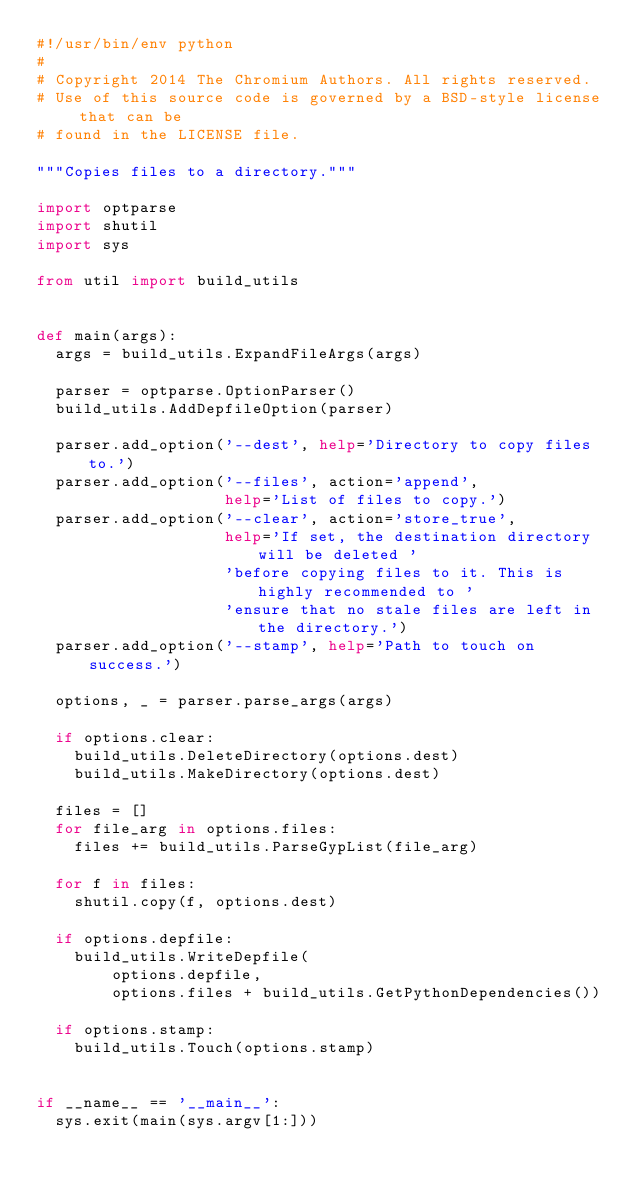Convert code to text. <code><loc_0><loc_0><loc_500><loc_500><_Python_>#!/usr/bin/env python
#
# Copyright 2014 The Chromium Authors. All rights reserved.
# Use of this source code is governed by a BSD-style license that can be
# found in the LICENSE file.

"""Copies files to a directory."""

import optparse
import shutil
import sys

from util import build_utils


def main(args):
  args = build_utils.ExpandFileArgs(args)

  parser = optparse.OptionParser()
  build_utils.AddDepfileOption(parser)

  parser.add_option('--dest', help='Directory to copy files to.')
  parser.add_option('--files', action='append',
                    help='List of files to copy.')
  parser.add_option('--clear', action='store_true',
                    help='If set, the destination directory will be deleted '
                    'before copying files to it. This is highly recommended to '
                    'ensure that no stale files are left in the directory.')
  parser.add_option('--stamp', help='Path to touch on success.')

  options, _ = parser.parse_args(args)

  if options.clear:
    build_utils.DeleteDirectory(options.dest)
    build_utils.MakeDirectory(options.dest)

  files = []
  for file_arg in options.files:
    files += build_utils.ParseGypList(file_arg)

  for f in files:
    shutil.copy(f, options.dest)

  if options.depfile:
    build_utils.WriteDepfile(
        options.depfile,
        options.files + build_utils.GetPythonDependencies())

  if options.stamp:
    build_utils.Touch(options.stamp)


if __name__ == '__main__':
  sys.exit(main(sys.argv[1:]))

</code> 